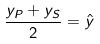<formula> <loc_0><loc_0><loc_500><loc_500>\frac { y _ { P } + y _ { S } } { 2 } = \hat { y }</formula> 